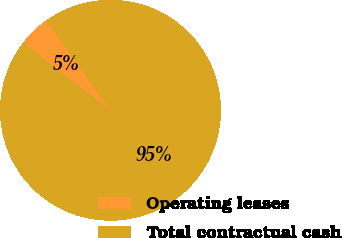Convert chart to OTSL. <chart><loc_0><loc_0><loc_500><loc_500><pie_chart><fcel>Operating leases<fcel>Total contractual cash<nl><fcel>4.66%<fcel>95.34%<nl></chart> 